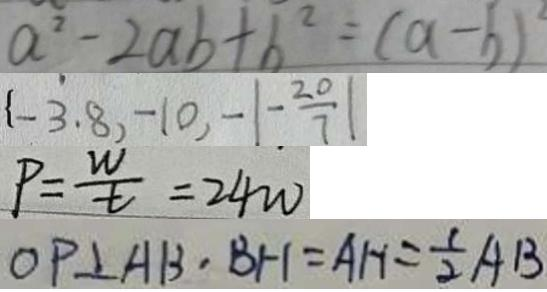Convert formula to latex. <formula><loc_0><loc_0><loc_500><loc_500>a ^ { 2 } - 2 a b + b ^ { 2 } = ( a - b ) ^ { 2 } 
 \{ - 3 . 8 , - 1 0 , - \vert - \frac { 2 0 } { 7 } \vert 
 P = \frac { w } { t } = 2 4 w 
 O P \bot A B , B H = A H = \frac { 1 } { 2 } A B</formula> 